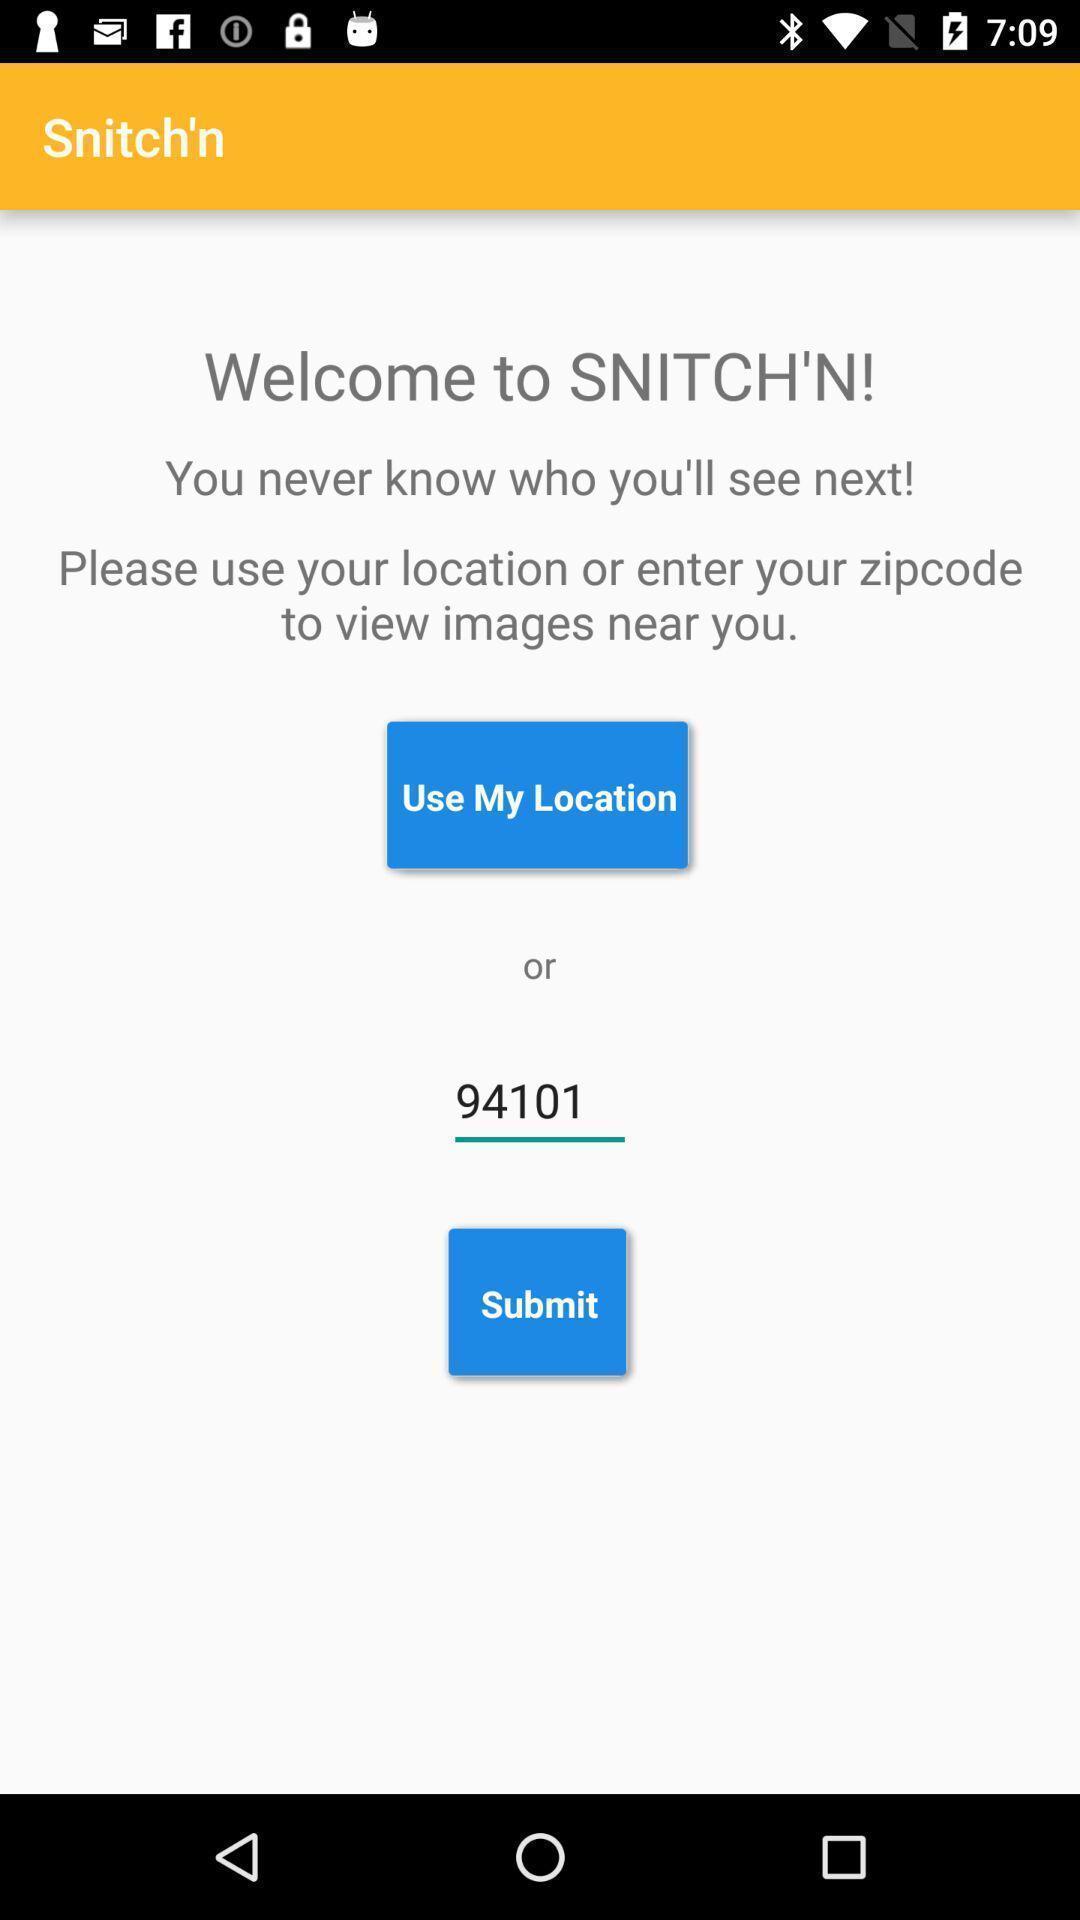Describe the content in this image. Welcome page. 